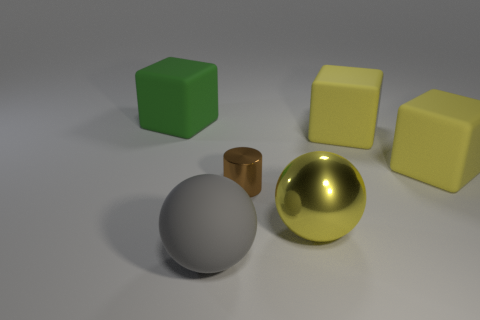Is there any other thing that has the same size as the brown thing?
Provide a succinct answer. No. How many large yellow things have the same shape as the big gray rubber thing?
Your response must be concise. 1. Is the number of gray balls that are in front of the big gray rubber object less than the number of matte blocks that are left of the yellow ball?
Keep it short and to the point. Yes. There is a large matte block to the left of the large gray ball; what number of green things are behind it?
Provide a short and direct response. 0. Is there a large yellow block?
Make the answer very short. Yes. Is there a ball that has the same material as the large gray object?
Offer a very short reply. No. Are there more big matte objects in front of the large yellow sphere than small metal objects that are in front of the cylinder?
Provide a short and direct response. Yes. Is the size of the yellow metallic thing the same as the green object?
Ensure brevity in your answer.  Yes. There is a big rubber object that is on the left side of the object that is in front of the shiny ball; what is its color?
Offer a very short reply. Green. The big metallic ball has what color?
Provide a succinct answer. Yellow. 